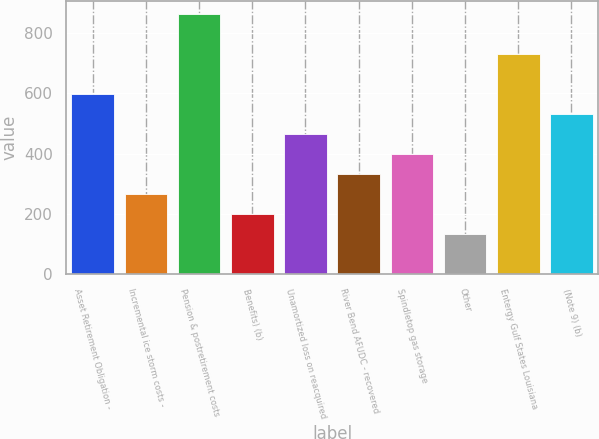Convert chart. <chart><loc_0><loc_0><loc_500><loc_500><bar_chart><fcel>Asset Retirement Obligation -<fcel>Incremental ice storm costs -<fcel>Pension & postretirement costs<fcel>Benefits) (b)<fcel>Unamortized loss on reacquired<fcel>River Bend AFUDC - recovered<fcel>Spindletop gas storage<fcel>Other<fcel>Entergy Gulf States Louisiana<fcel>(Note 9) (b)<nl><fcel>596.47<fcel>265.32<fcel>861.39<fcel>199.09<fcel>464.01<fcel>331.55<fcel>397.78<fcel>132.86<fcel>728.93<fcel>530.24<nl></chart> 